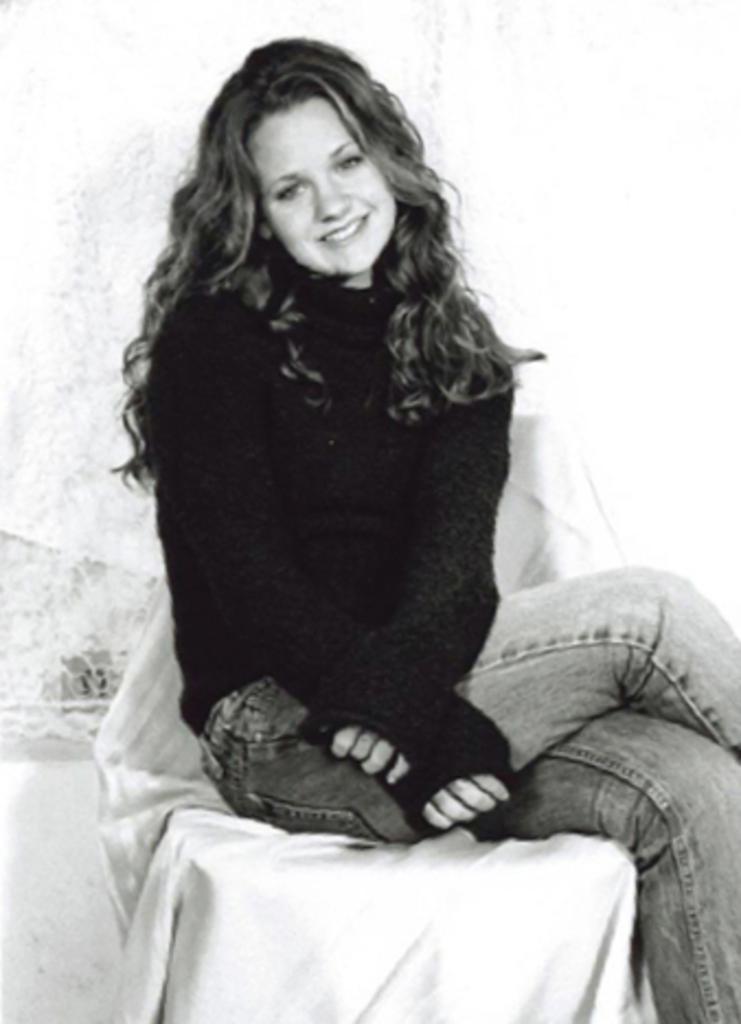How would you summarize this image in a sentence or two? This image is a black and white image. In the background there is a cloth and there is a wall. In the middle of the image a girl is sitting on the chair and she is with a smiling face. 